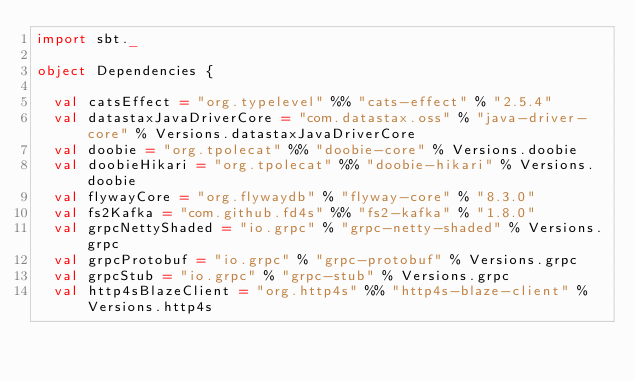Convert code to text. <code><loc_0><loc_0><loc_500><loc_500><_Scala_>import sbt._

object Dependencies {

  val catsEffect = "org.typelevel" %% "cats-effect" % "2.5.4"
  val datastaxJavaDriverCore = "com.datastax.oss" % "java-driver-core" % Versions.datastaxJavaDriverCore
  val doobie = "org.tpolecat" %% "doobie-core" % Versions.doobie
  val doobieHikari = "org.tpolecat" %% "doobie-hikari" % Versions.doobie
  val flywayCore = "org.flywaydb" % "flyway-core" % "8.3.0"
  val fs2Kafka = "com.github.fd4s" %% "fs2-kafka" % "1.8.0"
  val grpcNettyShaded = "io.grpc" % "grpc-netty-shaded" % Versions.grpc
  val grpcProtobuf = "io.grpc" % "grpc-protobuf" % Versions.grpc
  val grpcStub = "io.grpc" % "grpc-stub" % Versions.grpc
  val http4sBlazeClient = "org.http4s" %% "http4s-blaze-client" % Versions.http4s</code> 